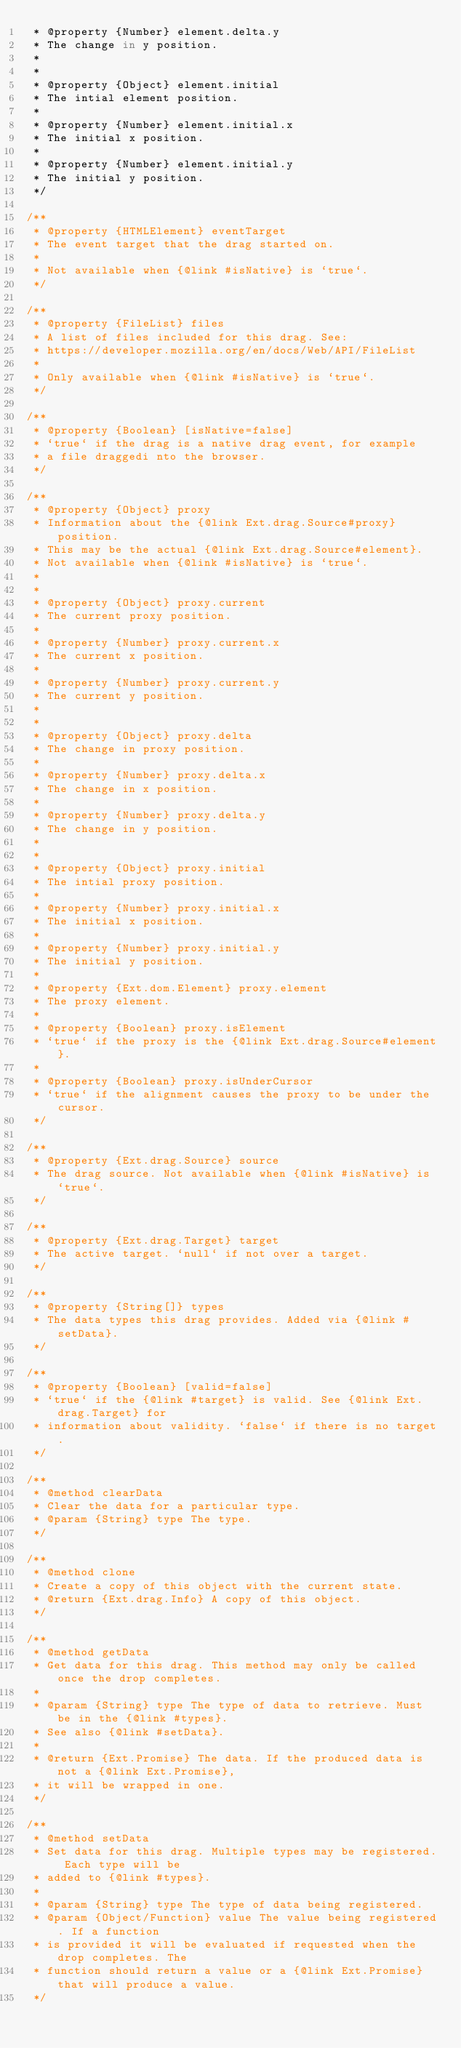Convert code to text. <code><loc_0><loc_0><loc_500><loc_500><_JavaScript_> * @property {Number} element.delta.y
 * The change in y position.
 *
 *
 * @property {Object} element.initial
 * The intial element position.
 *
 * @property {Number} element.initial.x
 * The initial x position.
 *
 * @property {Number} element.initial.y
 * The initial y position.
 */

/**
 * @property {HTMLElement} eventTarget
 * The event target that the drag started on.
 *
 * Not available when {@link #isNative} is `true`.
 */

/**
 * @property {FileList} files
 * A list of files included for this drag. See:
 * https://developer.mozilla.org/en/docs/Web/API/FileList
 *
 * Only available when {@link #isNative} is `true`.
 */

/**
 * @property {Boolean} [isNative=false]
 * `true` if the drag is a native drag event, for example
 * a file draggedi nto the browser.
 */

/**
 * @property {Object} proxy
 * Information about the {@link Ext.drag.Source#proxy} position.
 * This may be the actual {@link Ext.drag.Source#element}.
 * Not available when {@link #isNative} is `true`.
 *
 *
 * @property {Object} proxy.current
 * The current proxy position.
 *
 * @property {Number} proxy.current.x
 * The current x position.
 *
 * @property {Number} proxy.current.y
 * The current y position.
 *
 *
 * @property {Object} proxy.delta
 * The change in proxy position.
 *
 * @property {Number} proxy.delta.x
 * The change in x position.
 *
 * @property {Number} proxy.delta.y
 * The change in y position.
 *
 *
 * @property {Object} proxy.initial
 * The intial proxy position.
 *
 * @property {Number} proxy.initial.x
 * The initial x position.
 *
 * @property {Number} proxy.initial.y
 * The initial y position.
 *
 * @property {Ext.dom.Element} proxy.element
 * The proxy element.
 *
 * @property {Boolean} proxy.isElement
 * `true` if the proxy is the {@link Ext.drag.Source#element}.
 *
 * @property {Boolean} proxy.isUnderCursor
 * `true` if the alignment causes the proxy to be under the cursor.
 */

/**
 * @property {Ext.drag.Source} source
 * The drag source. Not available when {@link #isNative} is `true`.
 */

/**
 * @property {Ext.drag.Target} target
 * The active target. `null` if not over a target.
 */

/**
 * @property {String[]} types
 * The data types this drag provides. Added via {@link #setData}.
 */

/**
 * @property {Boolean} [valid=false]
 * `true` if the {@link #target} is valid. See {@link Ext.drag.Target} for
 * information about validity. `false` if there is no target.
 */

/**
 * @method clearData
 * Clear the data for a particular type.
 * @param {String} type The type.
 */

/**
 * @method clone
 * Create a copy of this object with the current state.
 * @return {Ext.drag.Info} A copy of this object.
 */

/**
 * @method getData
 * Get data for this drag. This method may only be called once the drop completes.
 *
 * @param {String} type The type of data to retrieve. Must be in the {@link #types}.
 * See also {@link #setData}.
 *
 * @return {Ext.Promise} The data. If the produced data is not a {@link Ext.Promise},
 * it will be wrapped in one.
 */

/**
 * @method setData
 * Set data for this drag. Multiple types may be registered. Each type will be
 * added to {@link #types}.
 *
 * @param {String} type The type of data being registered.
 * @param {Object/Function} value The value being registered. If a function
 * is provided it will be evaluated if requested when the drop completes. The
 * function should return a value or a {@link Ext.Promise} that will produce a value.
 */
</code> 